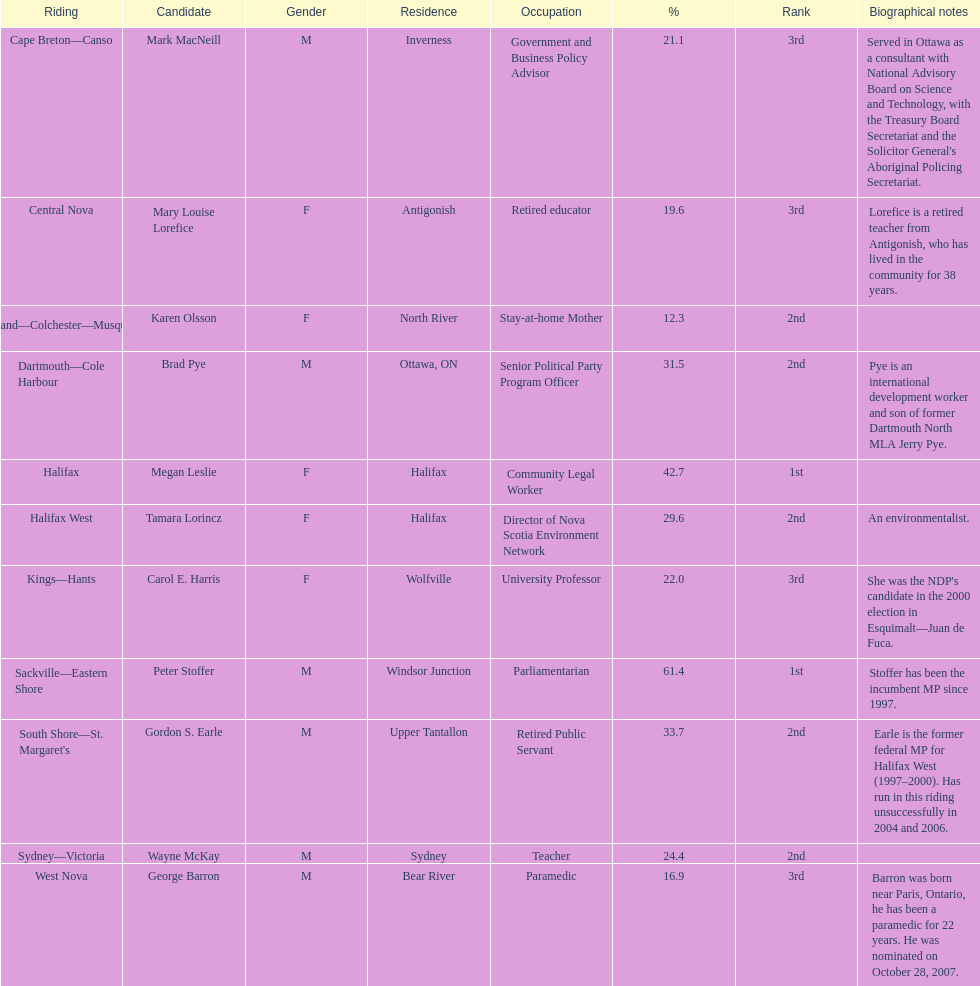How many candidates were from halifax? 2. 